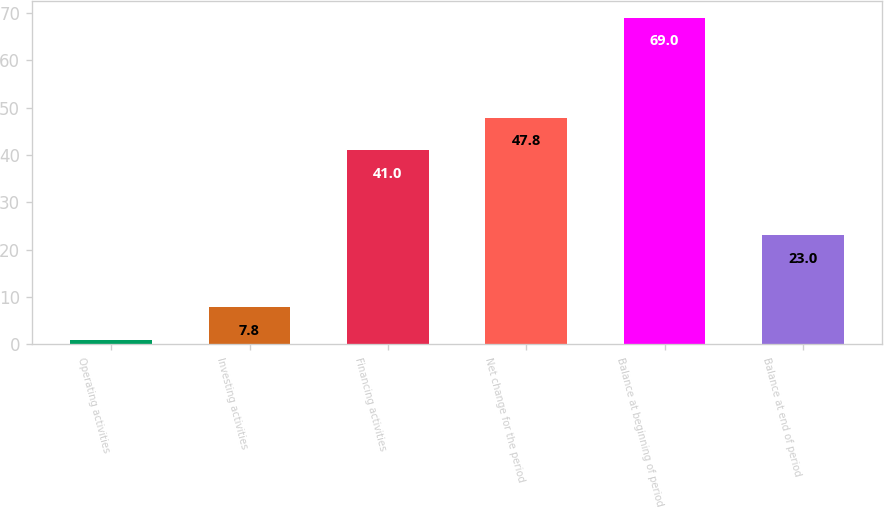<chart> <loc_0><loc_0><loc_500><loc_500><bar_chart><fcel>Operating activities<fcel>Investing activities<fcel>Financing activities<fcel>Net change for the period<fcel>Balance at beginning of period<fcel>Balance at end of period<nl><fcel>1<fcel>7.8<fcel>41<fcel>47.8<fcel>69<fcel>23<nl></chart> 